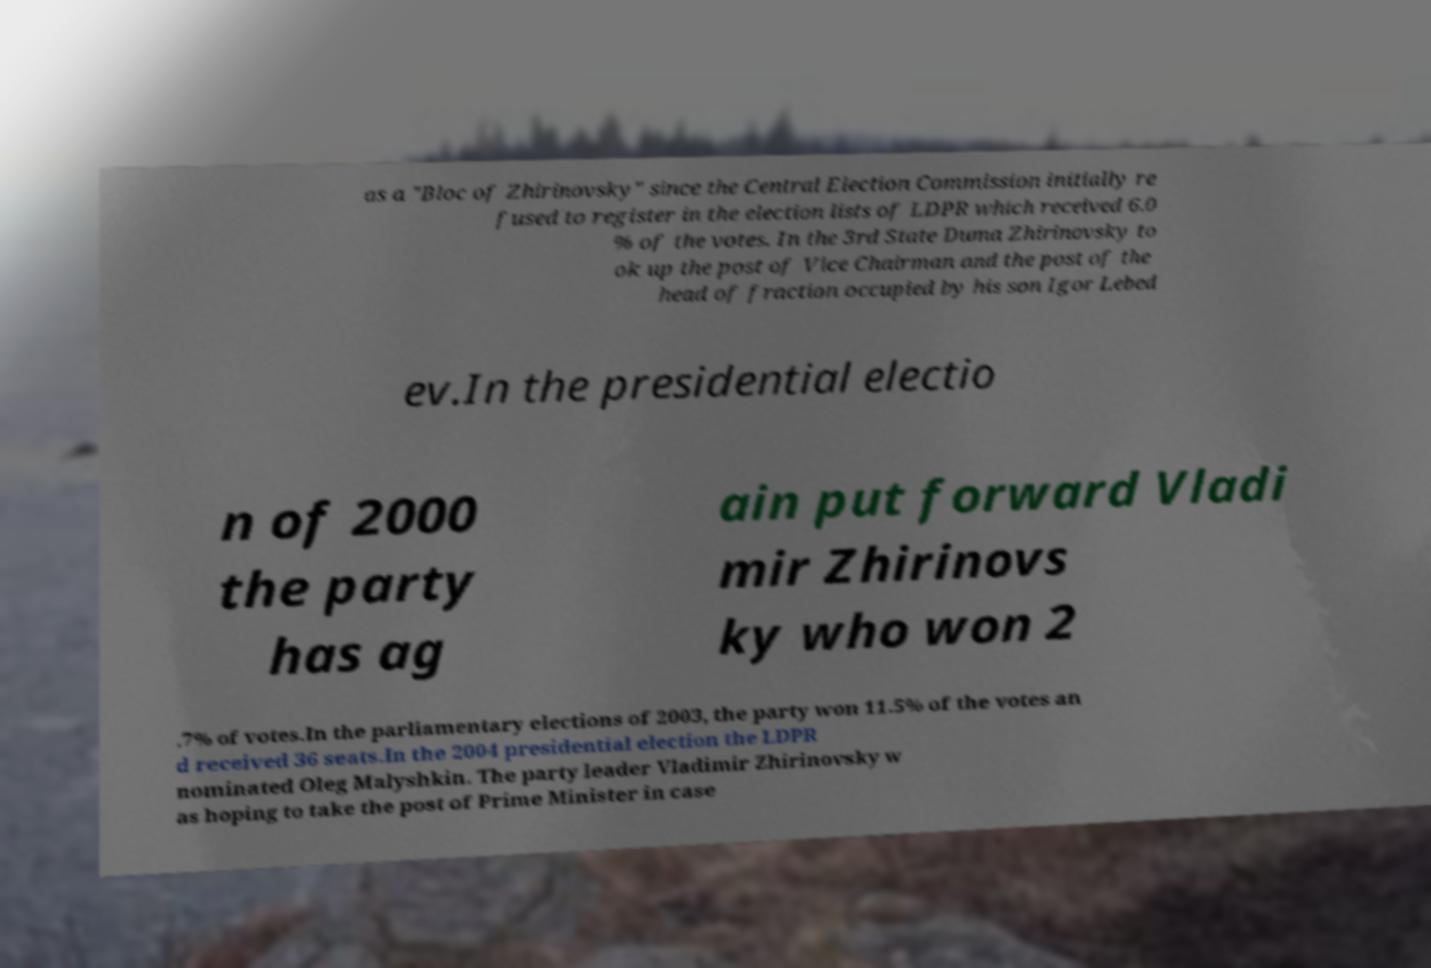Could you assist in decoding the text presented in this image and type it out clearly? as a "Bloc of Zhirinovsky" since the Central Election Commission initially re fused to register in the election lists of LDPR which received 6.0 % of the votes. In the 3rd State Duma Zhirinovsky to ok up the post of Vice Chairman and the post of the head of fraction occupied by his son Igor Lebed ev.In the presidential electio n of 2000 the party has ag ain put forward Vladi mir Zhirinovs ky who won 2 .7% of votes.In the parliamentary elections of 2003, the party won 11.5% of the votes an d received 36 seats.In the 2004 presidential election the LDPR nominated Oleg Malyshkin. The party leader Vladimir Zhirinovsky w as hoping to take the post of Prime Minister in case 